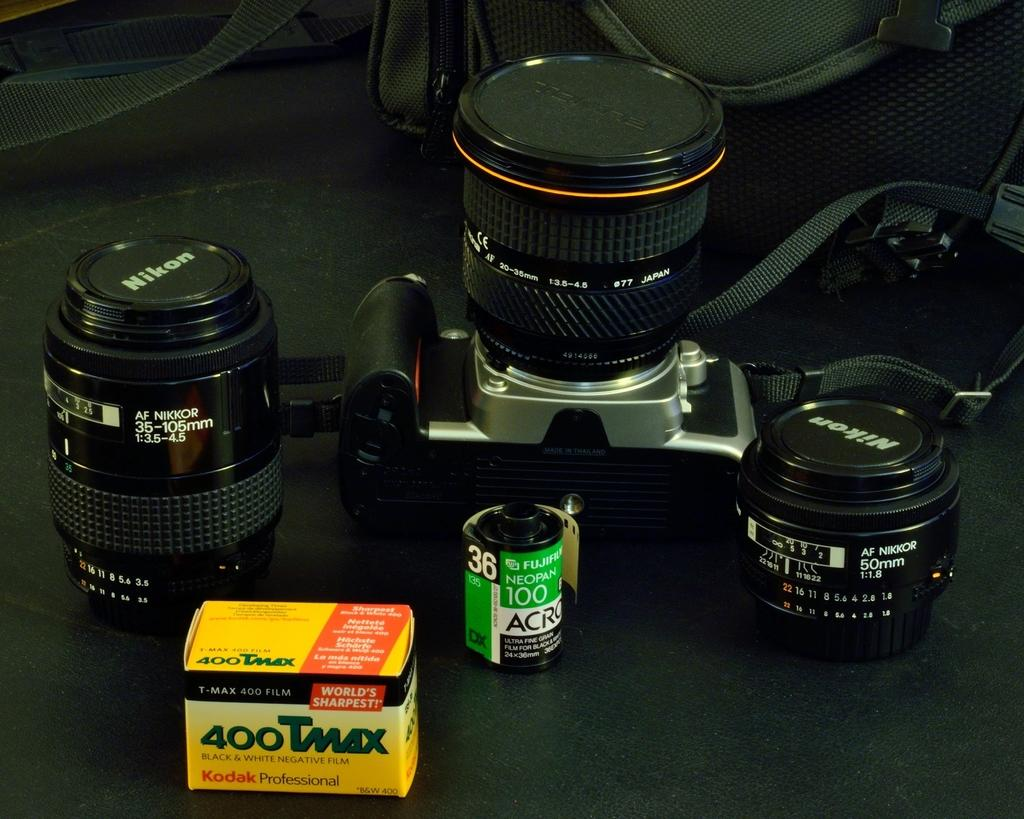What is the main object in the image? There is a camera in the image. What is associated with the camera in the image? There is a film roll and lenses in the image. What type of container is present in the image? There is a box in the image. What color is visible in the image? The black surface is visible in the image. What is located at the top of the image? There is a bag at the top of the image. How many cakes are being prepared by the maid in the image? There is no maid or cakes present in the image. What angle is the camera set at in the image? The angle of the camera is not mentioned in the image, as we are looking at the camera itself and not its viewpoint. 